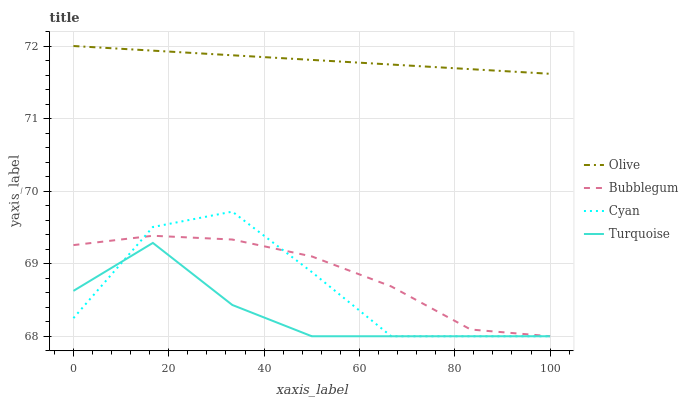Does Cyan have the minimum area under the curve?
Answer yes or no. No. Does Cyan have the maximum area under the curve?
Answer yes or no. No. Is Turquoise the smoothest?
Answer yes or no. No. Is Turquoise the roughest?
Answer yes or no. No. Does Cyan have the highest value?
Answer yes or no. No. Is Turquoise less than Olive?
Answer yes or no. Yes. Is Olive greater than Turquoise?
Answer yes or no. Yes. Does Turquoise intersect Olive?
Answer yes or no. No. 